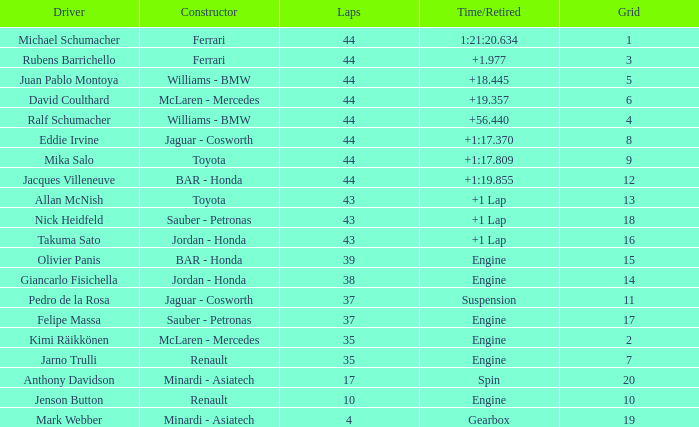445? 44.0. Write the full table. {'header': ['Driver', 'Constructor', 'Laps', 'Time/Retired', 'Grid'], 'rows': [['Michael Schumacher', 'Ferrari', '44', '1:21:20.634', '1'], ['Rubens Barrichello', 'Ferrari', '44', '+1.977', '3'], ['Juan Pablo Montoya', 'Williams - BMW', '44', '+18.445', '5'], ['David Coulthard', 'McLaren - Mercedes', '44', '+19.357', '6'], ['Ralf Schumacher', 'Williams - BMW', '44', '+56.440', '4'], ['Eddie Irvine', 'Jaguar - Cosworth', '44', '+1:17.370', '8'], ['Mika Salo', 'Toyota', '44', '+1:17.809', '9'], ['Jacques Villeneuve', 'BAR - Honda', '44', '+1:19.855', '12'], ['Allan McNish', 'Toyota', '43', '+1 Lap', '13'], ['Nick Heidfeld', 'Sauber - Petronas', '43', '+1 Lap', '18'], ['Takuma Sato', 'Jordan - Honda', '43', '+1 Lap', '16'], ['Olivier Panis', 'BAR - Honda', '39', 'Engine', '15'], ['Giancarlo Fisichella', 'Jordan - Honda', '38', 'Engine', '14'], ['Pedro de la Rosa', 'Jaguar - Cosworth', '37', 'Suspension', '11'], ['Felipe Massa', 'Sauber - Petronas', '37', 'Engine', '17'], ['Kimi Räikkönen', 'McLaren - Mercedes', '35', 'Engine', '2'], ['Jarno Trulli', 'Renault', '35', 'Engine', '7'], ['Anthony Davidson', 'Minardi - Asiatech', '17', 'Spin', '20'], ['Jenson Button', 'Renault', '10', 'Engine', '10'], ['Mark Webber', 'Minardi - Asiatech', '4', 'Gearbox', '19']]} 